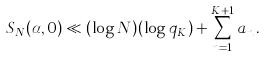Convert formula to latex. <formula><loc_0><loc_0><loc_500><loc_500>S _ { N } ( \alpha , 0 ) \ll ( \log N ) ( \log q _ { K } ) + \sum _ { n = 1 } ^ { K + 1 } a _ { n } \, .</formula> 